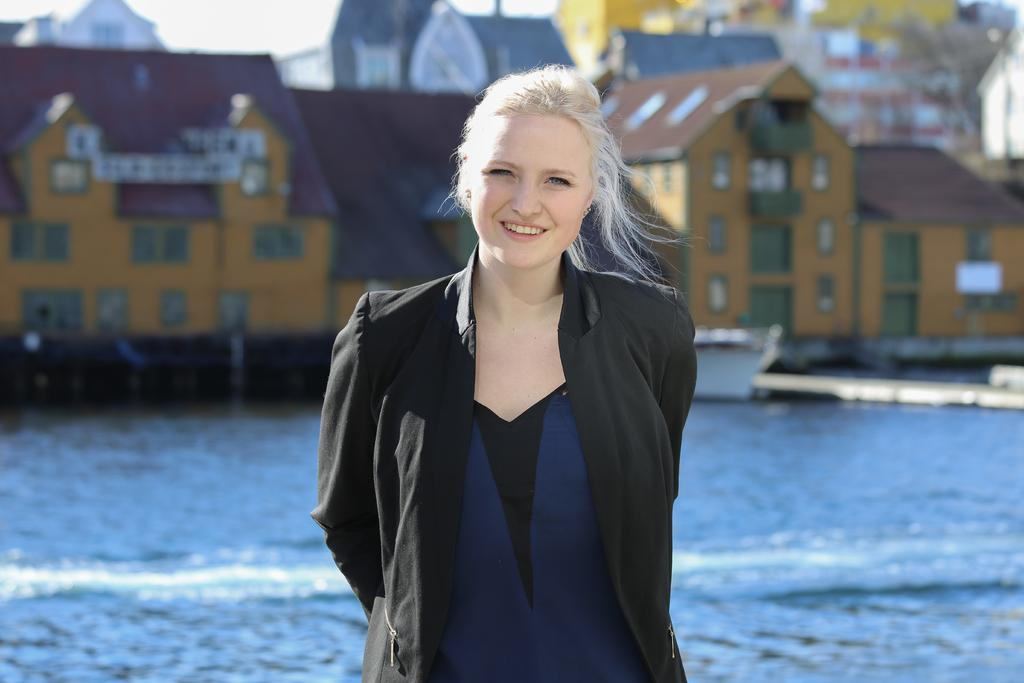What is the main subject of the image? There is a woman standing in the image. What type of structures can be seen in the background? There are houses with windows in the image. What natural element is visible in the image? There is water visible in the image. What type of bone can be seen floating in the water in the image? There is no bone visible in the image; it only shows a woman standing and houses with windows in the background. 